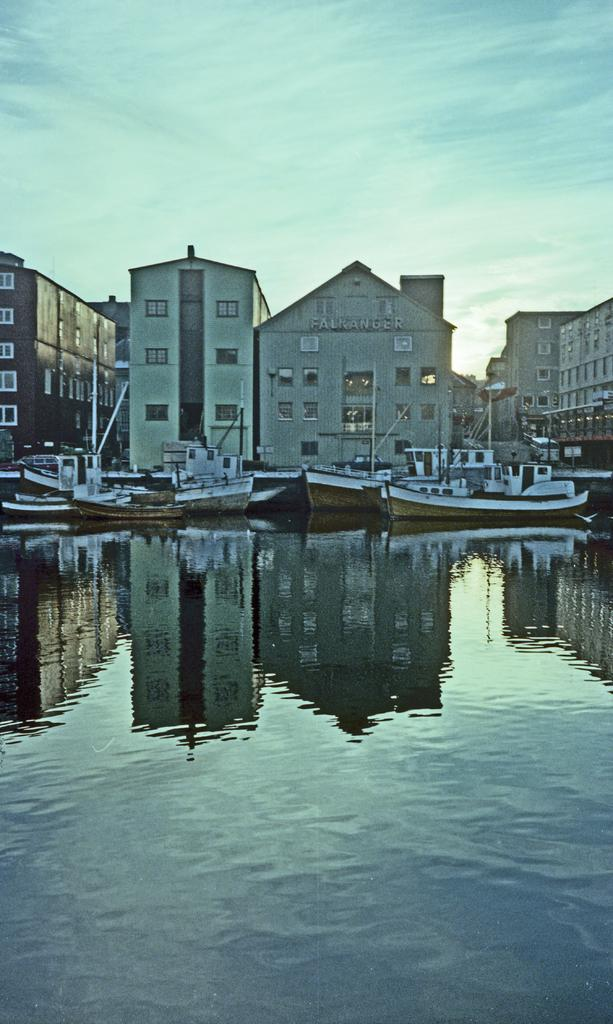What type of structures can be seen in the image? There are buildings in the image. What else is present in the image besides buildings? There are boats, water with a reflection, ground with objects, and the sky visible in the image. Can you see a crow reading a book on the ground in the image? There is no crow or book present in the image. 